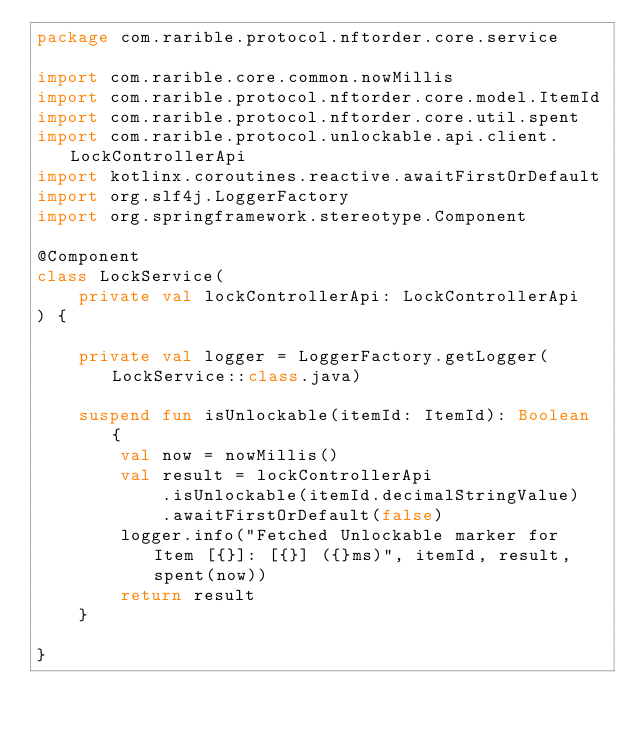<code> <loc_0><loc_0><loc_500><loc_500><_Kotlin_>package com.rarible.protocol.nftorder.core.service

import com.rarible.core.common.nowMillis
import com.rarible.protocol.nftorder.core.model.ItemId
import com.rarible.protocol.nftorder.core.util.spent
import com.rarible.protocol.unlockable.api.client.LockControllerApi
import kotlinx.coroutines.reactive.awaitFirstOrDefault
import org.slf4j.LoggerFactory
import org.springframework.stereotype.Component

@Component
class LockService(
    private val lockControllerApi: LockControllerApi
) {

    private val logger = LoggerFactory.getLogger(LockService::class.java)

    suspend fun isUnlockable(itemId: ItemId): Boolean {
        val now = nowMillis()
        val result = lockControllerApi
            .isUnlockable(itemId.decimalStringValue)
            .awaitFirstOrDefault(false)
        logger.info("Fetched Unlockable marker for Item [{}]: [{}] ({}ms)", itemId, result, spent(now))
        return result
    }

}</code> 